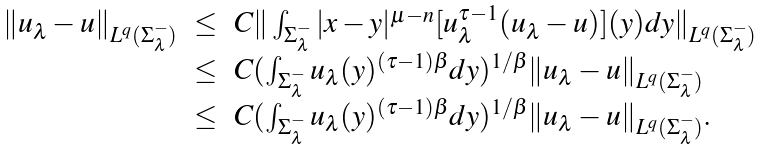<formula> <loc_0><loc_0><loc_500><loc_500>\begin{array} { l l l } \| u _ { \lambda } - u \| _ { L ^ { q } ( \Sigma _ { \lambda } ^ { - } ) } & \leq & C \| \int _ { \Sigma _ { \lambda } ^ { - } } | x - y | ^ { \mu - n } [ u _ { \lambda } ^ { \tau - 1 } ( u _ { \lambda } - u ) ] ( y ) d y \| _ { L ^ { q } ( \Sigma _ { \lambda } ^ { - } ) } \\ & \leq & C ( \int _ { \Sigma _ { \lambda } ^ { - } } u _ { \lambda } ( y ) ^ { ( \tau - 1 ) \beta } d y ) ^ { 1 / \beta } \| u _ { \lambda } - u \| _ { L ^ { q } ( \Sigma _ { \lambda } ^ { - } ) } \\ & \leq & C ( \int _ { \Sigma _ { \lambda } ^ { - } } u _ { \lambda } ( y ) ^ { ( \tau - 1 ) \beta } d y ) ^ { 1 / \beta } \| u _ { \lambda } - u \| _ { L ^ { q } ( \Sigma _ { \lambda } ^ { - } ) } . \, \\ \end{array}</formula> 